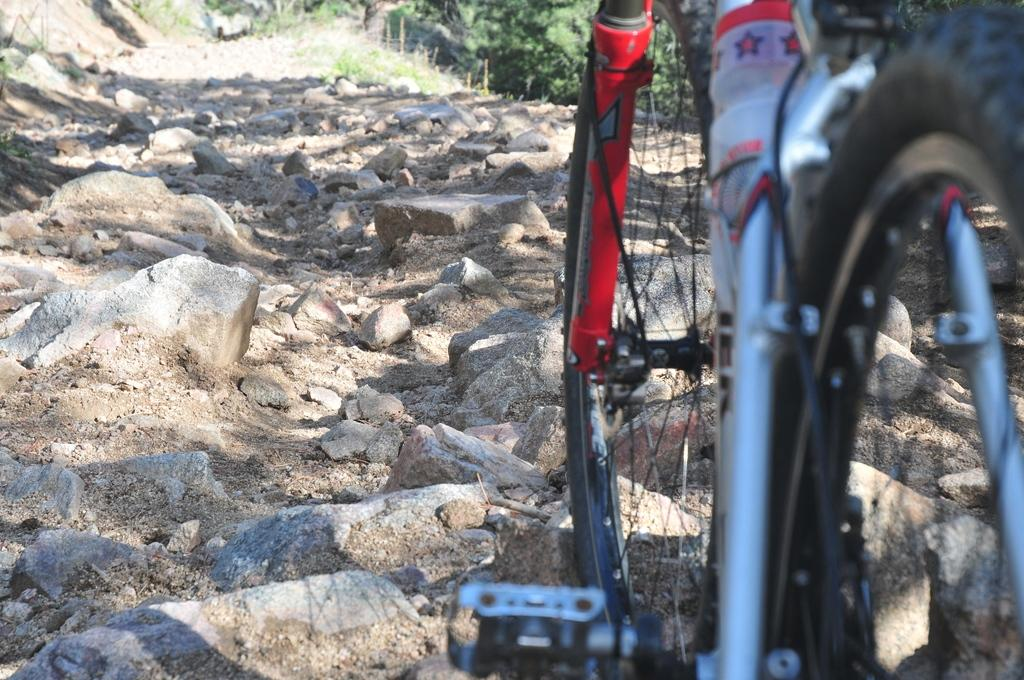What is the main mode of transportation in the image? There is a cycle in the image. What type of natural features can be seen in the image? There are rocks and trees in the image. What type of pocket can be seen in the image? There is no pocket present in the image. Can you recite a verse that is written on the rocks in the image? There is no verse written on the rocks in the image. 